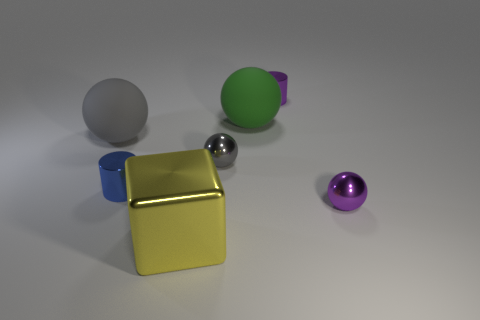Subtract 1 balls. How many balls are left? 3 Add 3 small purple things. How many objects exist? 10 Subtract all balls. How many objects are left? 3 Subtract 2 gray spheres. How many objects are left? 5 Subtract all yellow metal objects. Subtract all gray shiny balls. How many objects are left? 5 Add 2 purple shiny cylinders. How many purple shiny cylinders are left? 3 Add 3 big yellow things. How many big yellow things exist? 4 